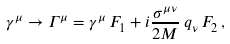<formula> <loc_0><loc_0><loc_500><loc_500>\gamma ^ { \mu } \rightarrow \Gamma ^ { \mu } = \gamma ^ { \mu } \, F _ { 1 } + i \frac { \sigma ^ { \mu \nu } } { 2 M } \, q _ { \nu } \, F _ { 2 } \, ,</formula> 